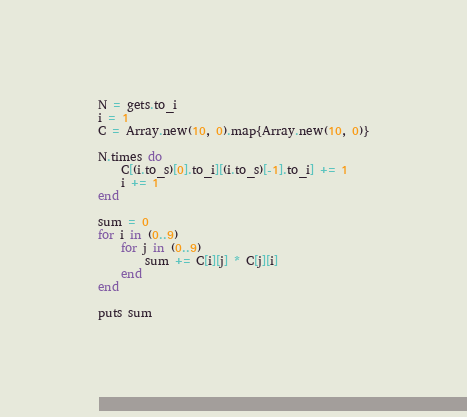Convert code to text. <code><loc_0><loc_0><loc_500><loc_500><_Ruby_>N = gets.to_i
i = 1
C = Array.new(10, 0).map{Array.new(10, 0)}

N.times do 
    C[(i.to_s)[0].to_i][(i.to_s)[-1].to_i] += 1
    i += 1
end

sum = 0
for i in (0..9)
    for j in (0..9)
        sum += C[i][j] * C[j][i]
    end
end

puts sum

</code> 